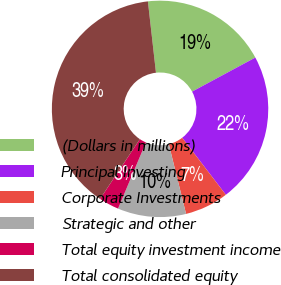Convert chart to OTSL. <chart><loc_0><loc_0><loc_500><loc_500><pie_chart><fcel>(Dollars in millions)<fcel>Principal Investing<fcel>Corporate Investments<fcel>Strategic and other<fcel>Total equity investment income<fcel>Total consolidated equity<nl><fcel>18.93%<fcel>22.46%<fcel>6.54%<fcel>10.21%<fcel>3.01%<fcel>38.85%<nl></chart> 